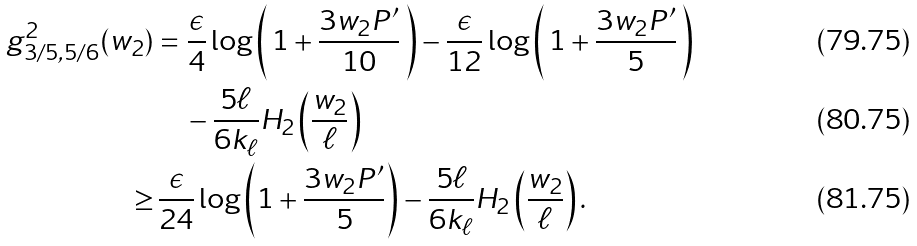<formula> <loc_0><loc_0><loc_500><loc_500>g _ { 3 / 5 , 5 / 6 } ^ { 2 } ( w _ { 2 } ) & = \frac { \epsilon } { 4 } \log \left ( \, 1 + \frac { 3 w _ { 2 } P ^ { \prime } } { 1 0 } \, \right ) - \frac { \epsilon } { 1 2 } \log \left ( \, 1 + \frac { 3 w _ { 2 } P ^ { \prime } } { 5 } \, \right ) \\ & \quad - \frac { 5 \ell } { 6 k _ { \ell } } H _ { 2 } \left ( \frac { w _ { 2 } } { \ell } \right ) \\ \geq & \, \frac { \epsilon } { 2 4 } \log \left ( 1 + \frac { 3 w _ { 2 } P ^ { \prime } } { 5 } \right ) - \frac { 5 \ell } { 6 k _ { \ell } } H _ { 2 } \left ( \frac { w _ { 2 } } { \ell } \right ) .</formula> 